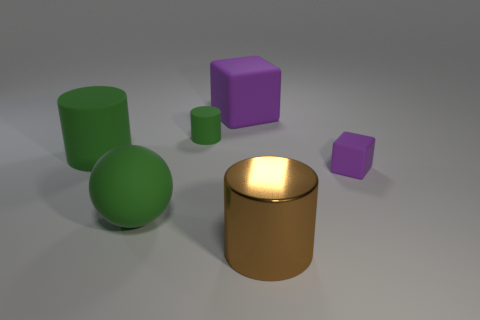Subtract all large green cylinders. How many cylinders are left? 2 Subtract all green cylinders. How many cylinders are left? 1 Subtract 2 blocks. How many blocks are left? 0 Subtract all blue blocks. Subtract all cyan balls. How many blocks are left? 2 Subtract all blue balls. How many green cylinders are left? 2 Subtract all small green matte cylinders. Subtract all large shiny cylinders. How many objects are left? 4 Add 6 big brown shiny things. How many big brown shiny things are left? 7 Add 6 small green cylinders. How many small green cylinders exist? 7 Add 2 tiny purple objects. How many objects exist? 8 Subtract 0 red balls. How many objects are left? 6 